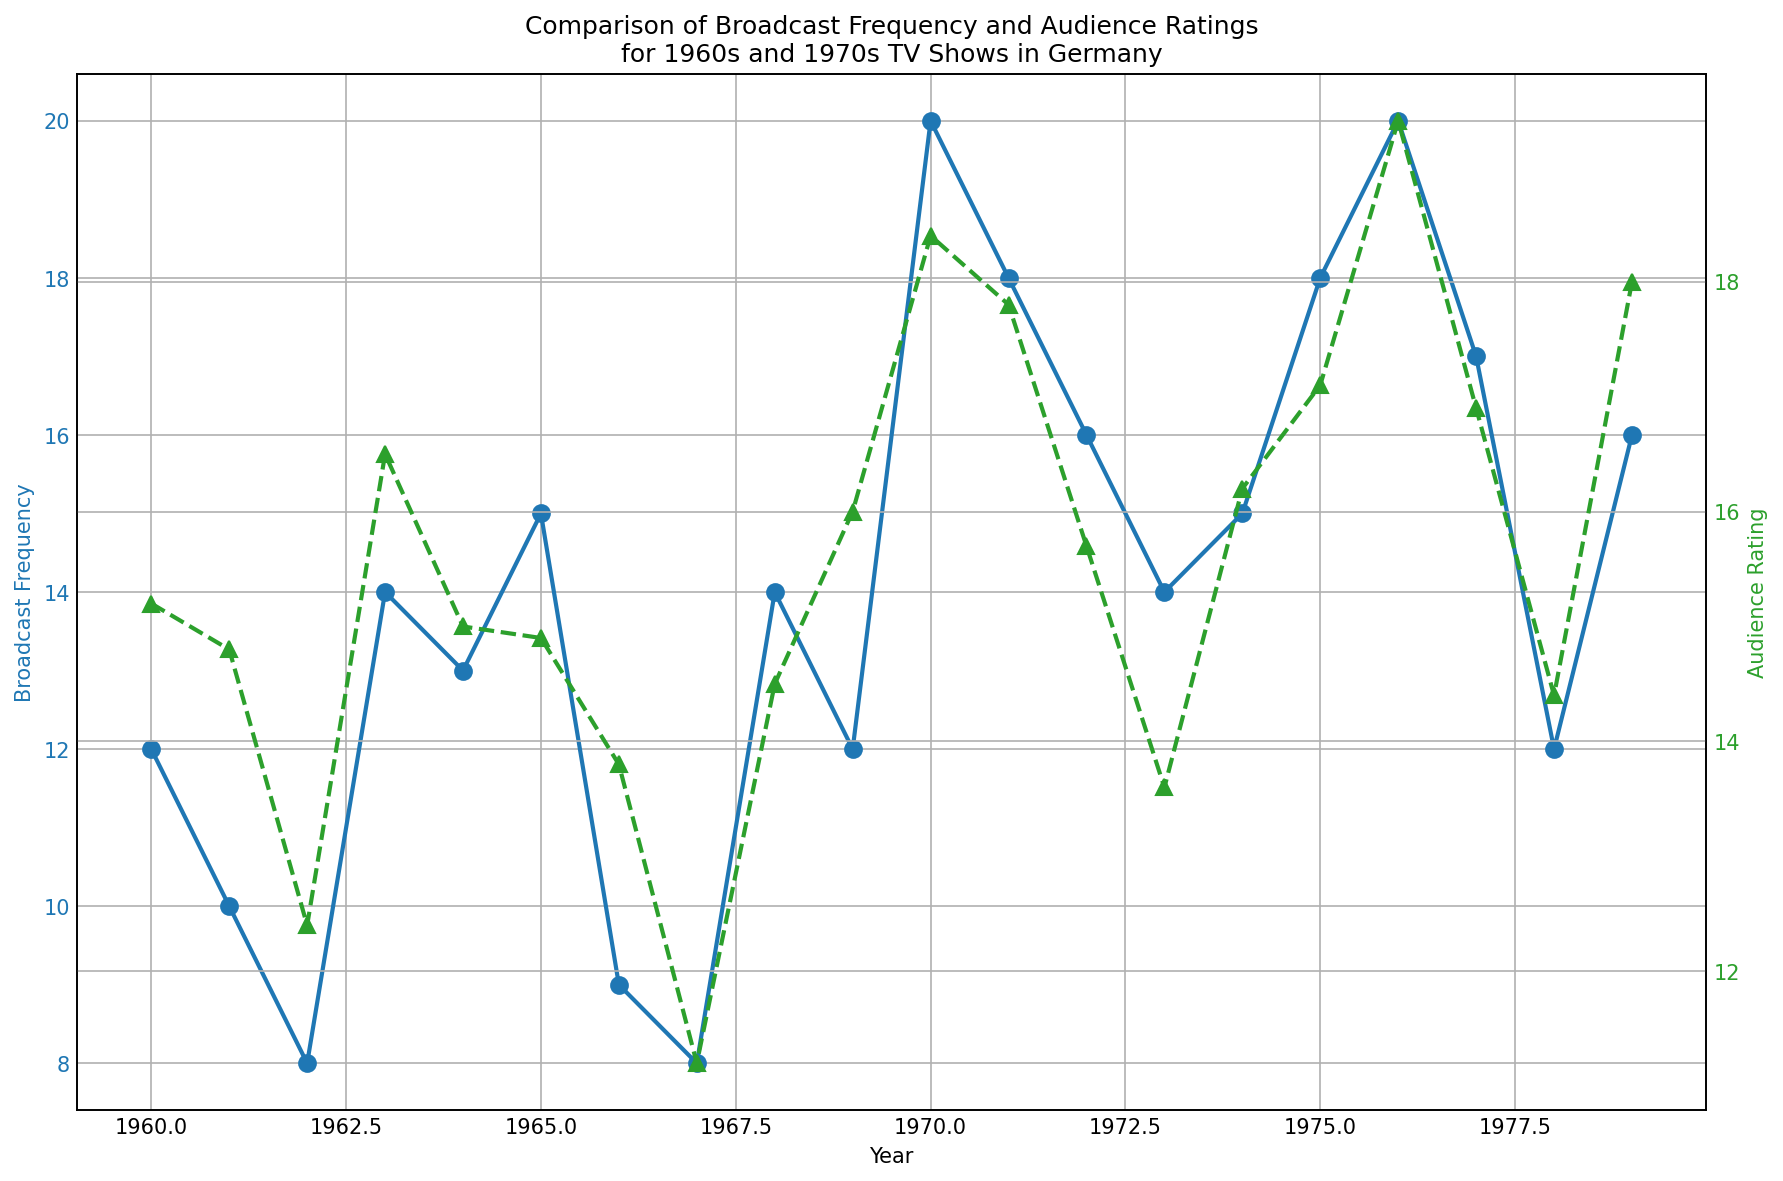What's the broadcast frequency of "Tatort" in 1970? To find the answer, locate the year 1970 on the x-axis, then check the value on the primary y-axis, labeled "Broadcast Frequency" for the point marked on 1970.
Answer: 20 Which year had the highest audience rating? Search the entire green (secondary) line plot representing audience ratings, and find the highest upward point. Then, check which year corresponds to this point on the x-axis.
Answer: 1976 Compare the audience rating of "Stahlnetz" in 1960 and "Nonstop Nonsens" in 1976. Which one is higher, and by how much? Locate the audience rating for the year 1960 and the year 1976 on the secondary y-axis. "Stahlnetz" in 1960 has 15.2 and "Nonstop Nonsens" in 1976 has 19.4. Subtract 15.2 from 19.4 to find how much higher it is.
Answer: Nonstop Nonsens by 4.2 What is the average broadcast frequency of TV shows for the years 1969 and 1979? Locate the broadcast frequencies for the years 1969 and 1979 on the primary y-axis. The values are 12 and 16 respectively. Add them up and divide by 2 to get the average (12 + 16) / 2 = 14.
Answer: 14 Which genre had the most consistent audience rating over the years, crime or comedy? Visually compare the green line segments representing the crime (blue markers) and comedy (red markers) genres for stability. Observe which genre has less fluctuation in ratings.
Answer: Crime Is there a noticeable trend between broadcast frequency and audience rating from 1960 to 1979? Review if an increase or decrease in broadcast frequency consistently corresponds to a change in audience rating. Look for any patterns where both lines (blue and green) move in tandem or diverge over time.
Answer: No clear trend What was the broadcast frequency range for drama TV shows between 1960 and 1979? Identify the points marked for Drama on the x-axis. Note the broadcast frequencies for each year and determine the minimum and maximum values among them.
Answer: 8 to 16 Did any show have both below-average broadcast frequency and below-average audience rating? Calculate the overall average for broadcast frequency and audience rating. Then, verify if any show has both values below these averages by checking each point on the plot.
Answer: Yes (e.g., "Familie Schmidt" in 1962) 